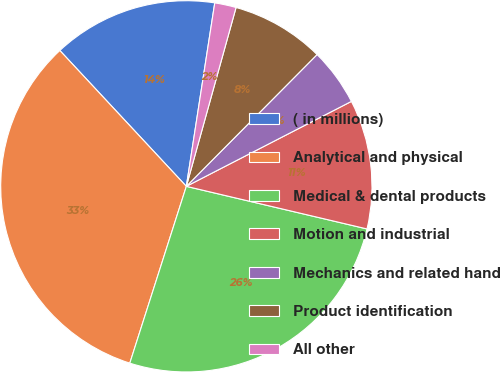Convert chart to OTSL. <chart><loc_0><loc_0><loc_500><loc_500><pie_chart><fcel>( in millions)<fcel>Analytical and physical<fcel>Medical & dental products<fcel>Motion and industrial<fcel>Mechanics and related hand<fcel>Product identification<fcel>All other<nl><fcel>14.38%<fcel>33.14%<fcel>26.24%<fcel>11.25%<fcel>5.0%<fcel>8.12%<fcel>1.87%<nl></chart> 